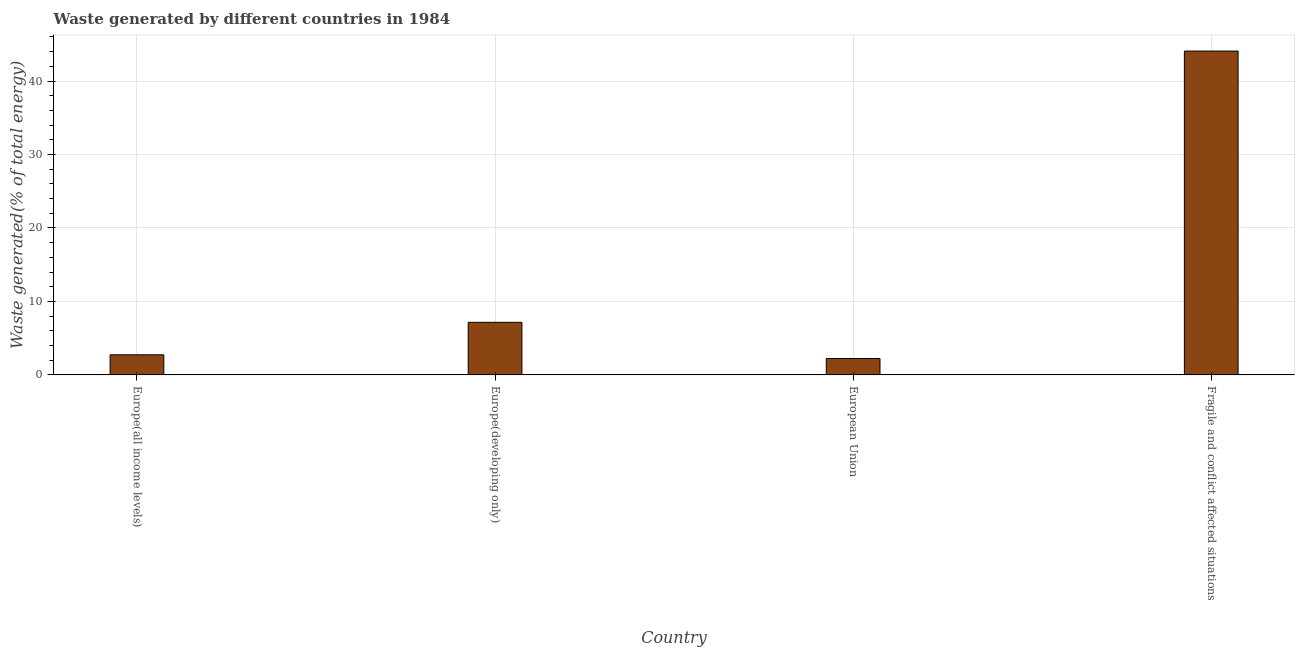Does the graph contain any zero values?
Offer a very short reply. No. Does the graph contain grids?
Provide a succinct answer. Yes. What is the title of the graph?
Your answer should be very brief. Waste generated by different countries in 1984. What is the label or title of the Y-axis?
Keep it short and to the point. Waste generated(% of total energy). What is the amount of waste generated in Fragile and conflict affected situations?
Ensure brevity in your answer.  44.08. Across all countries, what is the maximum amount of waste generated?
Offer a terse response. 44.08. Across all countries, what is the minimum amount of waste generated?
Offer a terse response. 2.23. In which country was the amount of waste generated maximum?
Your answer should be compact. Fragile and conflict affected situations. What is the sum of the amount of waste generated?
Ensure brevity in your answer.  56.21. What is the difference between the amount of waste generated in Europe(all income levels) and European Union?
Offer a very short reply. 0.5. What is the average amount of waste generated per country?
Make the answer very short. 14.05. What is the median amount of waste generated?
Provide a short and direct response. 4.95. What is the ratio of the amount of waste generated in Europe(all income levels) to that in Europe(developing only)?
Your answer should be very brief. 0.38. Is the amount of waste generated in Europe(developing only) less than that in Fragile and conflict affected situations?
Your response must be concise. Yes. Is the difference between the amount of waste generated in Europe(developing only) and European Union greater than the difference between any two countries?
Offer a terse response. No. What is the difference between the highest and the second highest amount of waste generated?
Make the answer very short. 36.92. Is the sum of the amount of waste generated in Europe(developing only) and Fragile and conflict affected situations greater than the maximum amount of waste generated across all countries?
Offer a terse response. Yes. What is the difference between the highest and the lowest amount of waste generated?
Ensure brevity in your answer.  41.84. Are all the bars in the graph horizontal?
Make the answer very short. No. What is the Waste generated(% of total energy) in Europe(all income levels)?
Offer a terse response. 2.74. What is the Waste generated(% of total energy) of Europe(developing only)?
Your answer should be very brief. 7.16. What is the Waste generated(% of total energy) of European Union?
Provide a short and direct response. 2.23. What is the Waste generated(% of total energy) in Fragile and conflict affected situations?
Offer a very short reply. 44.08. What is the difference between the Waste generated(% of total energy) in Europe(all income levels) and Europe(developing only)?
Provide a short and direct response. -4.42. What is the difference between the Waste generated(% of total energy) in Europe(all income levels) and European Union?
Provide a succinct answer. 0.5. What is the difference between the Waste generated(% of total energy) in Europe(all income levels) and Fragile and conflict affected situations?
Make the answer very short. -41.34. What is the difference between the Waste generated(% of total energy) in Europe(developing only) and European Union?
Ensure brevity in your answer.  4.92. What is the difference between the Waste generated(% of total energy) in Europe(developing only) and Fragile and conflict affected situations?
Your answer should be compact. -36.92. What is the difference between the Waste generated(% of total energy) in European Union and Fragile and conflict affected situations?
Offer a terse response. -41.84. What is the ratio of the Waste generated(% of total energy) in Europe(all income levels) to that in Europe(developing only)?
Keep it short and to the point. 0.38. What is the ratio of the Waste generated(% of total energy) in Europe(all income levels) to that in European Union?
Keep it short and to the point. 1.23. What is the ratio of the Waste generated(% of total energy) in Europe(all income levels) to that in Fragile and conflict affected situations?
Your response must be concise. 0.06. What is the ratio of the Waste generated(% of total energy) in Europe(developing only) to that in European Union?
Ensure brevity in your answer.  3.2. What is the ratio of the Waste generated(% of total energy) in Europe(developing only) to that in Fragile and conflict affected situations?
Offer a terse response. 0.16. What is the ratio of the Waste generated(% of total energy) in European Union to that in Fragile and conflict affected situations?
Offer a very short reply. 0.05. 